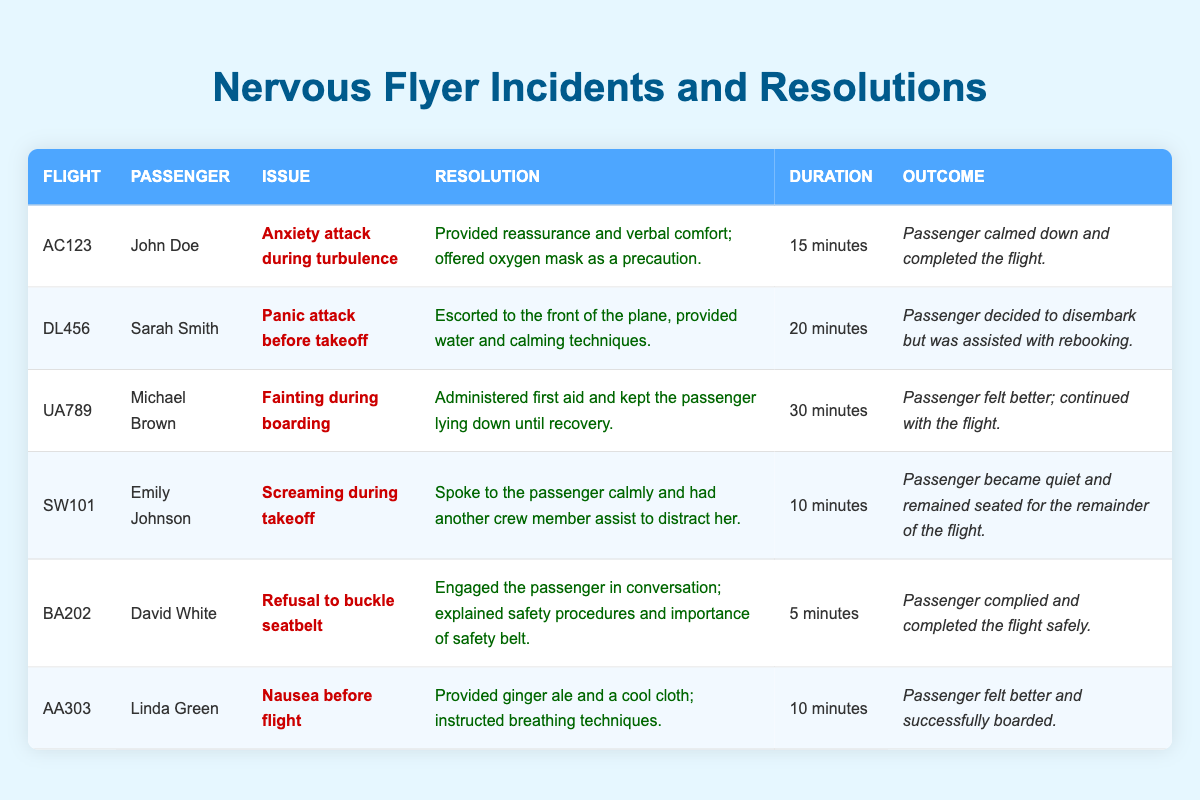What was the longest duration of an incident recorded? The durations of the incidents are: 15 minutes, 20 minutes, 30 minutes, 10 minutes, 5 minutes, and 10 minutes. The longest among these is 30 minutes from Michael Brown's incident for fainting during boarding.
Answer: 30 minutes How many passengers completed the flight after their incidents? Reviewing the outcomes, the passengers who completed the flight are John Doe, Michael Brown, Emily Johnson, and David White. Counting them gives a total of 4 passengers.
Answer: 4 Did any passenger decide to disembark? Looking through the outcomes, Sarah Smith is the only passenger who decided to disembark after her panic attack before takeoff.
Answer: Yes What percentage of incidents had a calming conversation as a resolution? There are 6 incidents in total. The resolutions that involved a calming conversation include John Doe, Emily Johnson, and David White's incidents, totaling 3 incidents. The percentage is (3/6) * 100 = 50%.
Answer: 50% Who had the quickest resolution time? The incident with the quickest resolution time is David White's refusal to buckle the seatbelt, which lasted 5 minutes.
Answer: David White What is the average duration of all incidents? The durations are 15, 20, 30, 10, 5, and 10 minutes. Their sum is 15 + 20 + 30 + 10 + 5 + 10 = 90 minutes. Dividing by the number of incidents (6) gives an average of 90/6 = 15 minutes.
Answer: 15 minutes Did any incident involve the administration of first aid? Michael Brown's incident involved administering first aid after fainting during boarding, making him the only case with this detail.
Answer: Yes How many incidents took place during boarding? Looking at the incidents, Michael Brown’s incident happened during boarding, while others occurred at different times. Therefore, there is only one incident during boarding.
Answer: 1 